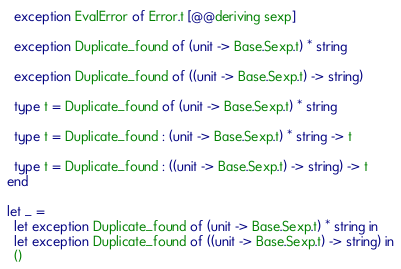Convert code to text. <code><loc_0><loc_0><loc_500><loc_500><_OCaml_>  exception EvalError of Error.t [@@deriving sexp]

  exception Duplicate_found of (unit -> Base.Sexp.t) * string

  exception Duplicate_found of ((unit -> Base.Sexp.t) -> string)

  type t = Duplicate_found of (unit -> Base.Sexp.t) * string

  type t = Duplicate_found : (unit -> Base.Sexp.t) * string -> t

  type t = Duplicate_found : ((unit -> Base.Sexp.t) -> string) -> t
end

let _ =
  let exception Duplicate_found of (unit -> Base.Sexp.t) * string in
  let exception Duplicate_found of ((unit -> Base.Sexp.t) -> string) in
  ()
</code> 